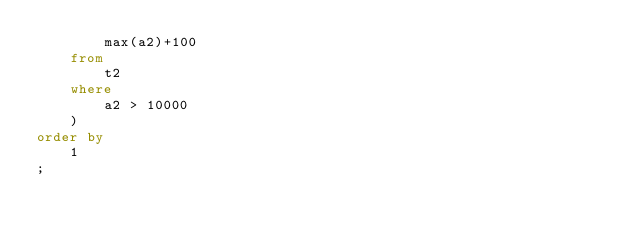Convert code to text. <code><loc_0><loc_0><loc_500><loc_500><_SQL_>		max(a2)+100
	from
		t2
	where	
		a2 > 10000
	)
order by 
	1
;

</code> 